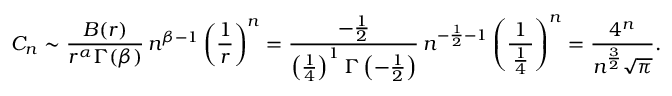Convert formula to latex. <formula><loc_0><loc_0><loc_500><loc_500>C _ { n } \sim { \frac { B ( r ) } { r ^ { \alpha } \Gamma ( \beta ) } } \, n ^ { \beta - 1 } \left ( { \frac { 1 } { r } } \right ) ^ { n } = { \frac { - { \frac { 1 } { 2 } } } { \left ( { \frac { 1 } { 4 } } \right ) ^ { 1 } \Gamma \left ( - { \frac { 1 } { 2 } } \right ) } } \, n ^ { - { \frac { 1 } { 2 } } - 1 } \left ( { \frac { 1 } { \, { \frac { 1 } { 4 } } \, } } \right ) ^ { n } = { \frac { 4 ^ { n } } { n ^ { \frac { 3 } { 2 } } { \sqrt { \pi } } } } .</formula> 